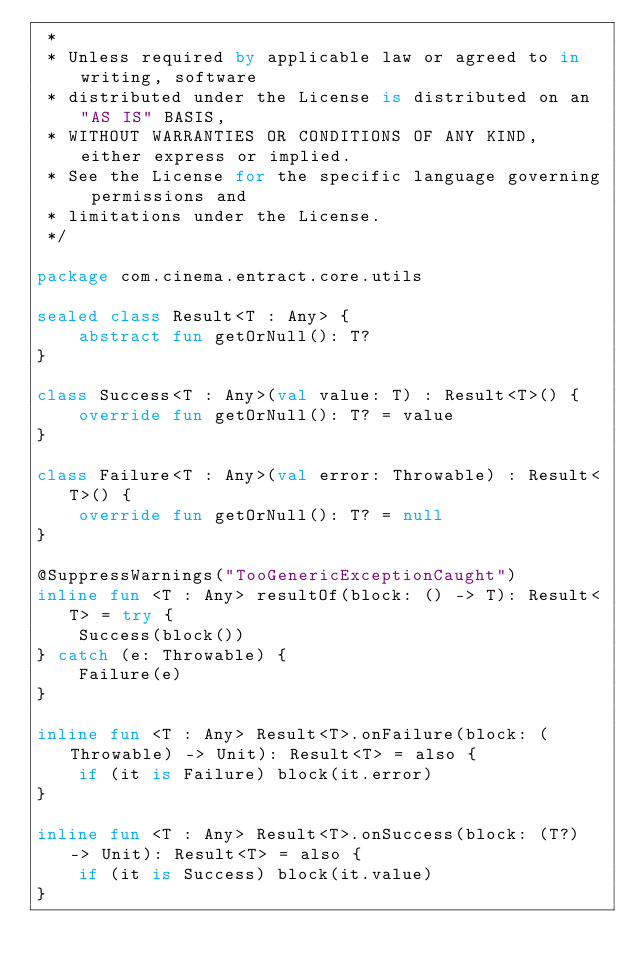<code> <loc_0><loc_0><loc_500><loc_500><_Kotlin_> *
 * Unless required by applicable law or agreed to in writing, software
 * distributed under the License is distributed on an "AS IS" BASIS,
 * WITHOUT WARRANTIES OR CONDITIONS OF ANY KIND, either express or implied.
 * See the License for the specific language governing permissions and
 * limitations under the License.
 */

package com.cinema.entract.core.utils

sealed class Result<T : Any> {
    abstract fun getOrNull(): T?
}

class Success<T : Any>(val value: T) : Result<T>() {
    override fun getOrNull(): T? = value
}

class Failure<T : Any>(val error: Throwable) : Result<T>() {
    override fun getOrNull(): T? = null
}

@SuppressWarnings("TooGenericExceptionCaught")
inline fun <T : Any> resultOf(block: () -> T): Result<T> = try {
    Success(block())
} catch (e: Throwable) {
    Failure(e)
}

inline fun <T : Any> Result<T>.onFailure(block: (Throwable) -> Unit): Result<T> = also {
    if (it is Failure) block(it.error)
}

inline fun <T : Any> Result<T>.onSuccess(block: (T?) -> Unit): Result<T> = also {
    if (it is Success) block(it.value)
}
</code> 